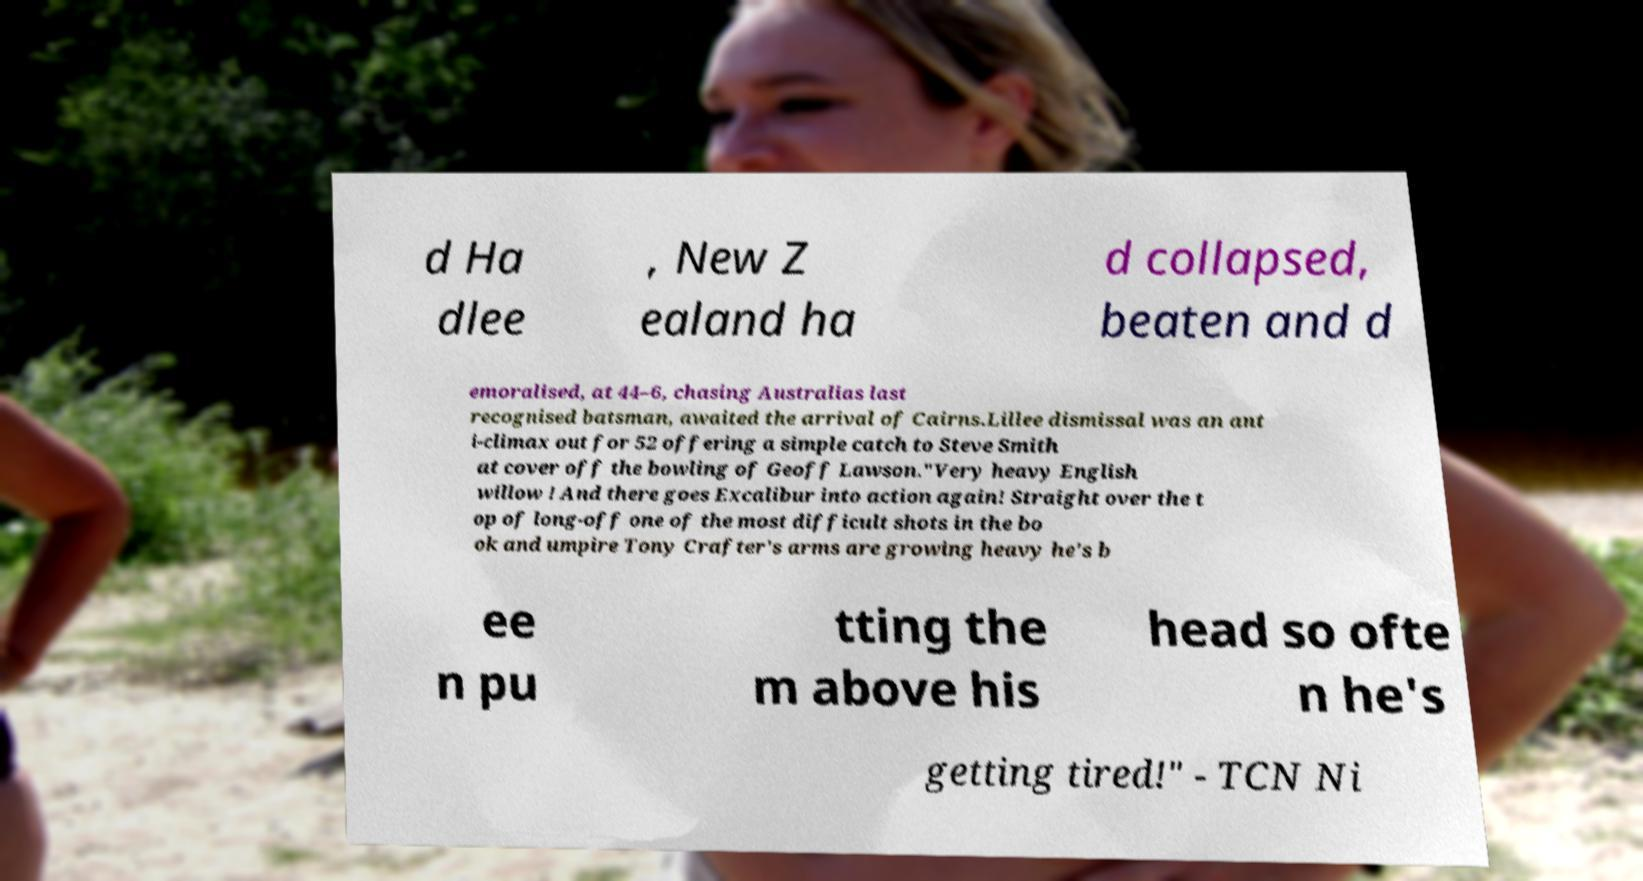Please identify and transcribe the text found in this image. d Ha dlee , New Z ealand ha d collapsed, beaten and d emoralised, at 44–6, chasing Australias last recognised batsman, awaited the arrival of Cairns.Lillee dismissal was an ant i-climax out for 52 offering a simple catch to Steve Smith at cover off the bowling of Geoff Lawson."Very heavy English willow ! And there goes Excalibur into action again! Straight over the t op of long-off one of the most difficult shots in the bo ok and umpire Tony Crafter's arms are growing heavy he's b ee n pu tting the m above his head so ofte n he's getting tired!" - TCN Ni 